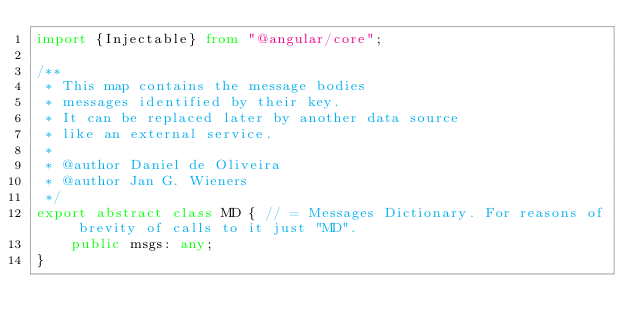<code> <loc_0><loc_0><loc_500><loc_500><_TypeScript_>import {Injectable} from "@angular/core";

/**
 * This map contains the message bodies
 * messages identified by their key.
 * It can be replaced later by another data source
 * like an external service.
 *
 * @author Daniel de Oliveira
 * @author Jan G. Wieners
 */
export abstract class MD { // = Messages Dictionary. For reasons of brevity of calls to it just "MD".
    public msgs: any;
}</code> 